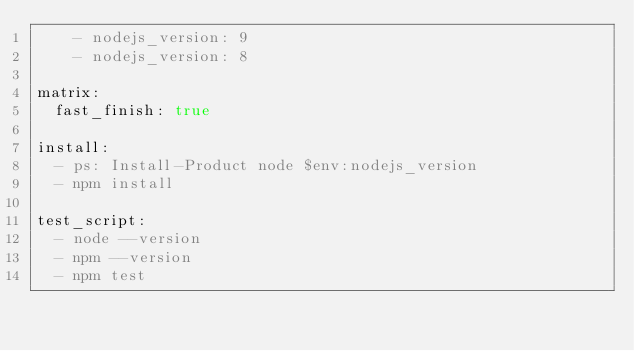Convert code to text. <code><loc_0><loc_0><loc_500><loc_500><_YAML_>    - nodejs_version: 9
    - nodejs_version: 8

matrix:
  fast_finish: true

install:
  - ps: Install-Product node $env:nodejs_version
  - npm install

test_script:
  - node --version
  - npm --version
  - npm test
</code> 